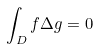Convert formula to latex. <formula><loc_0><loc_0><loc_500><loc_500>\int _ { D } f \Delta g = 0</formula> 